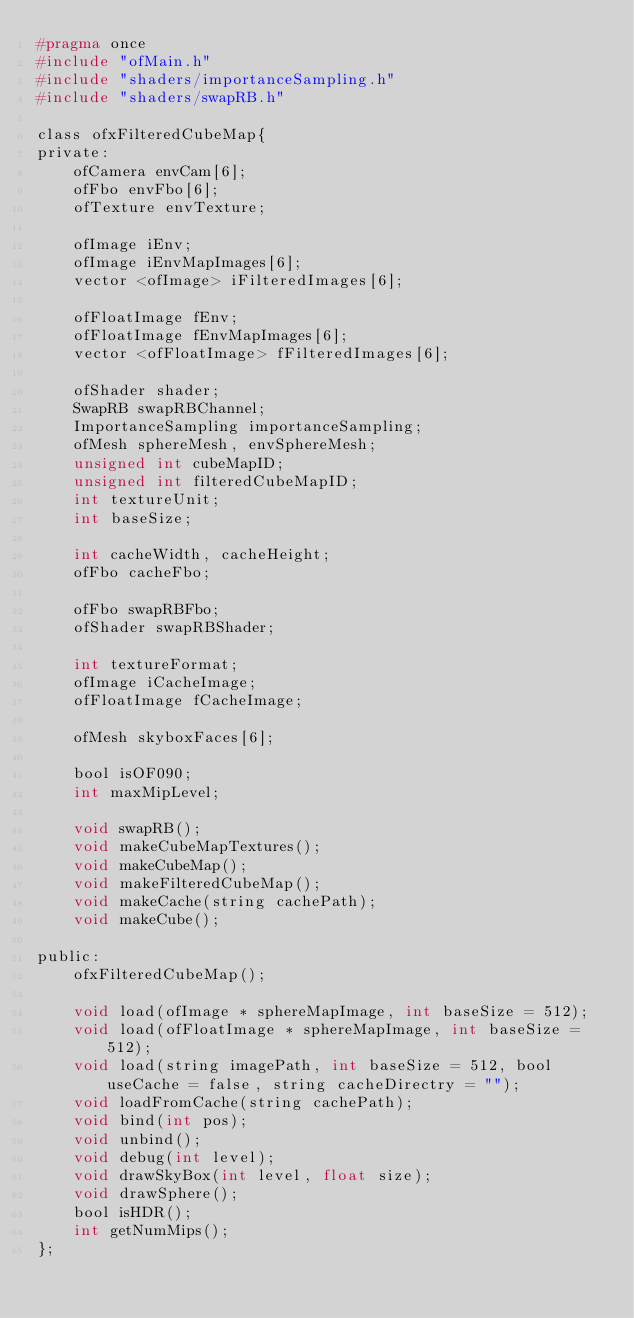Convert code to text. <code><loc_0><loc_0><loc_500><loc_500><_C_>#pragma once
#include "ofMain.h"
#include "shaders/importanceSampling.h"
#include "shaders/swapRB.h"

class ofxFilteredCubeMap{
private:
    ofCamera envCam[6];
    ofFbo envFbo[6];
    ofTexture envTexture;
    
    ofImage iEnv;
    ofImage iEnvMapImages[6];
    vector <ofImage> iFilteredImages[6];
    
    ofFloatImage fEnv;
    ofFloatImage fEnvMapImages[6];
    vector <ofFloatImage> fFilteredImages[6];
    
    ofShader shader;
    SwapRB swapRBChannel;
    ImportanceSampling importanceSampling;
    ofMesh sphereMesh, envSphereMesh;
    unsigned int cubeMapID;
    unsigned int filteredCubeMapID;
    int textureUnit;
    int baseSize;
    
    int cacheWidth, cacheHeight;
    ofFbo cacheFbo;
    
    ofFbo swapRBFbo;
    ofShader swapRBShader;
    
    int textureFormat;
    ofImage iCacheImage;
    ofFloatImage fCacheImage;
    
    ofMesh skyboxFaces[6];
    
    bool isOF090;
    int maxMipLevel;
    
    void swapRB();
    void makeCubeMapTextures();
    void makeCubeMap();
    void makeFilteredCubeMap();
    void makeCache(string cachePath);
    void makeCube();
    
public:
    ofxFilteredCubeMap();
    
    void load(ofImage * sphereMapImage, int baseSize = 512);
    void load(ofFloatImage * sphereMapImage, int baseSize = 512);
    void load(string imagePath, int baseSize = 512, bool useCache = false, string cacheDirectry = "");
    void loadFromCache(string cachePath);
    void bind(int pos);
    void unbind();
    void debug(int level);
    void drawSkyBox(int level, float size);
    void drawSphere();
    bool isHDR();
    int getNumMips();
};</code> 